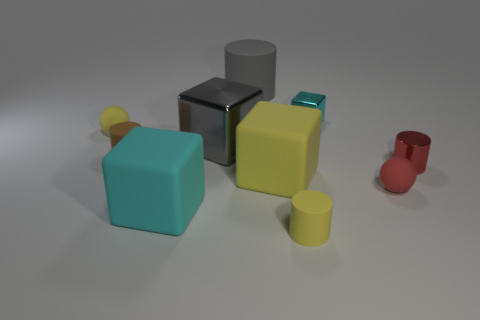Subtract all tiny yellow cylinders. How many cylinders are left? 3 Subtract all cubes. How many objects are left? 6 Subtract 3 blocks. How many blocks are left? 1 Subtract all red cylinders. How many cylinders are left? 3 Subtract all gray balls. How many cyan cylinders are left? 0 Subtract all gray matte things. Subtract all cyan metal spheres. How many objects are left? 9 Add 2 red spheres. How many red spheres are left? 3 Add 1 tiny yellow cylinders. How many tiny yellow cylinders exist? 2 Subtract 0 blue cylinders. How many objects are left? 10 Subtract all green cubes. Subtract all purple cylinders. How many cubes are left? 4 